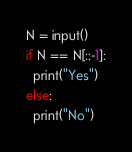Convert code to text. <code><loc_0><loc_0><loc_500><loc_500><_Python_>N = input()
if N == N[::-1]:
  print("Yes")
else:
  print("No")</code> 